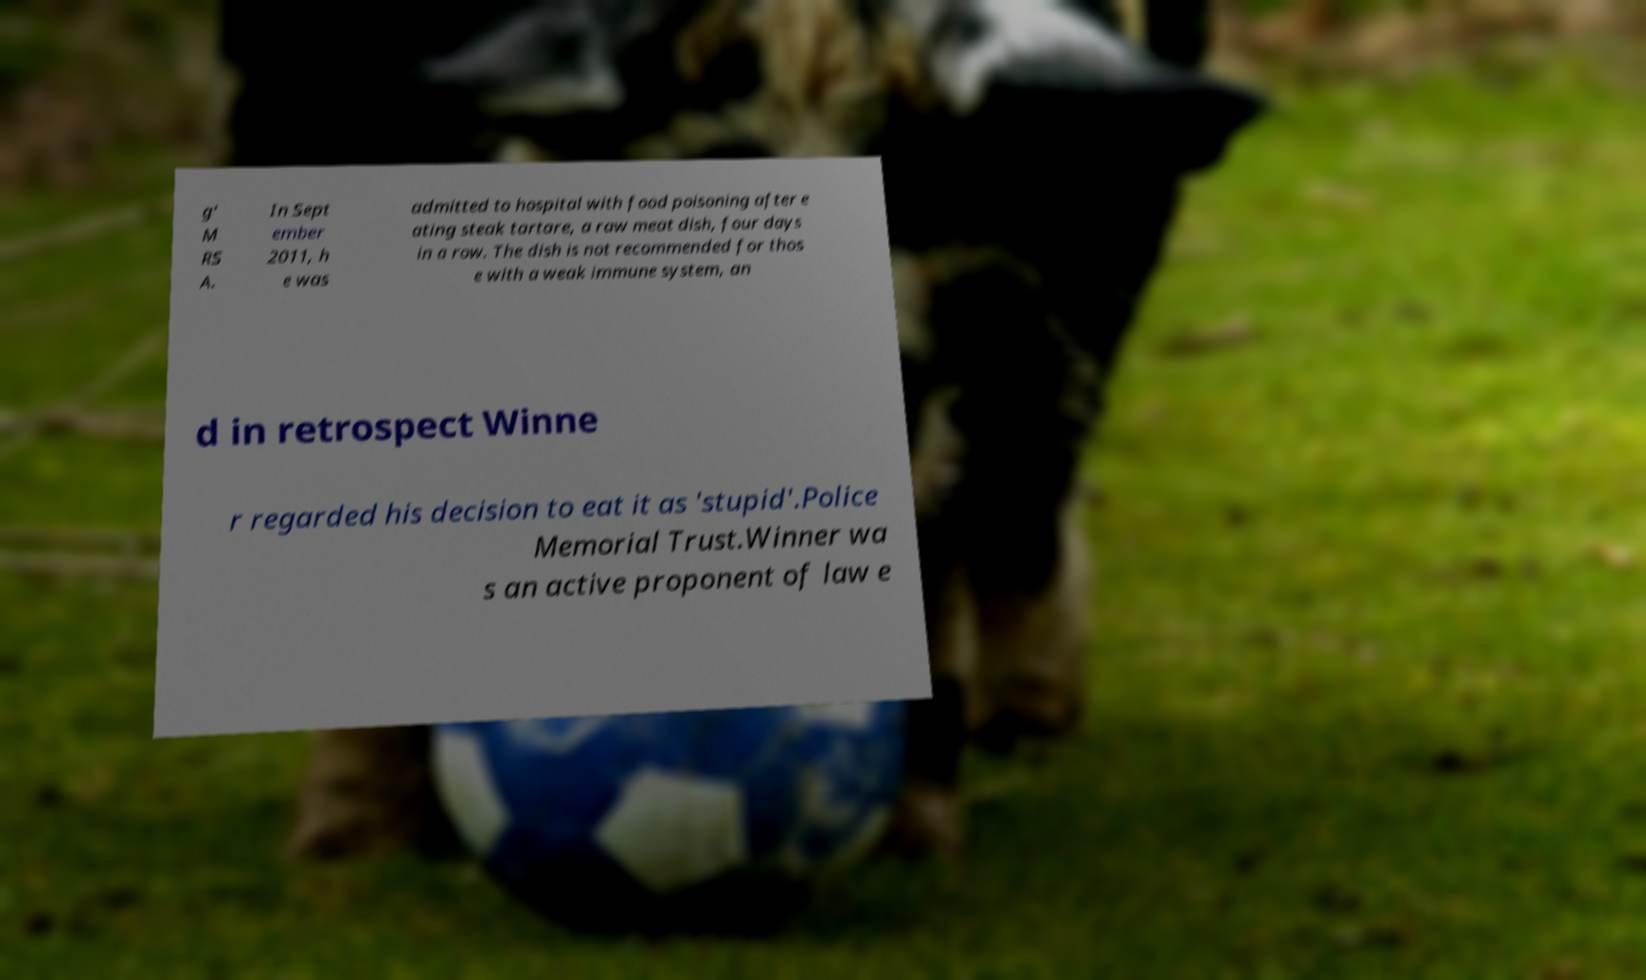What messages or text are displayed in this image? I need them in a readable, typed format. g' M RS A. In Sept ember 2011, h e was admitted to hospital with food poisoning after e ating steak tartare, a raw meat dish, four days in a row. The dish is not recommended for thos e with a weak immune system, an d in retrospect Winne r regarded his decision to eat it as 'stupid'.Police Memorial Trust.Winner wa s an active proponent of law e 